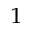Convert formula to latex. <formula><loc_0><loc_0><loc_500><loc_500>_ { 1 }</formula> 